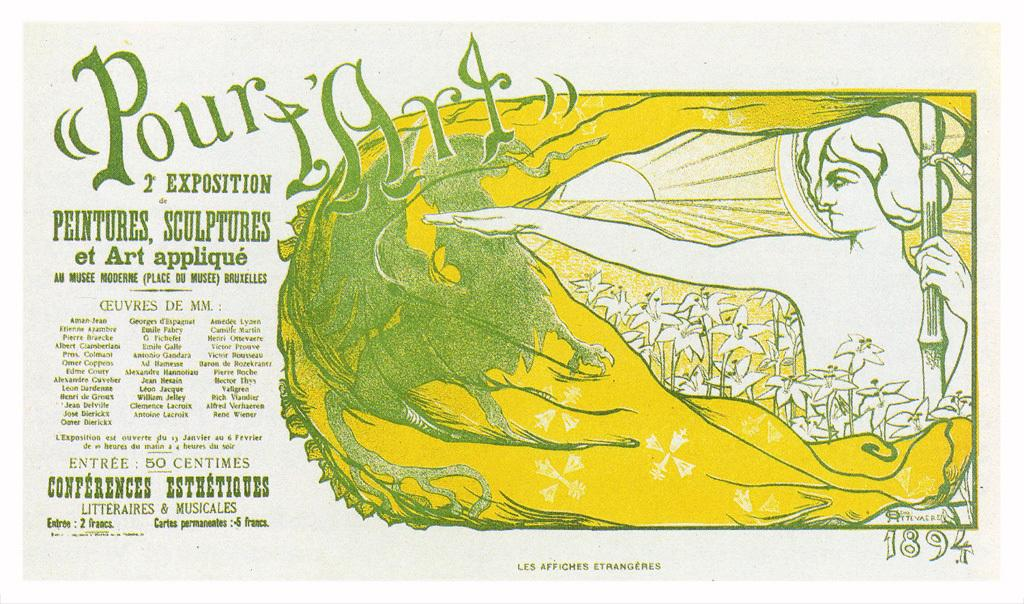<image>
Provide a brief description of the given image. A poster with the colors green and yellow, that says pour art 